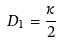Convert formula to latex. <formula><loc_0><loc_0><loc_500><loc_500>D _ { 1 } = \frac { \kappa } { 2 }</formula> 